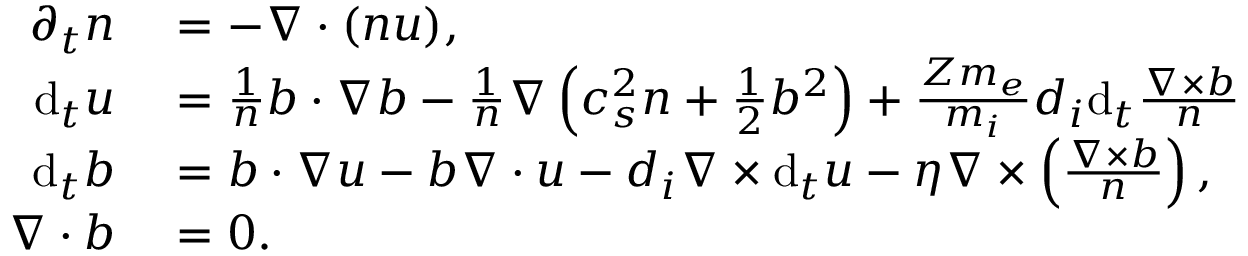<formula> <loc_0><loc_0><loc_500><loc_500>\begin{array} { r l } { \partial _ { t } n } & = - \nabla \cdot ( n u ) , } \\ { d _ { t } u } & = \frac { 1 } { n } b \cdot \nabla b - \frac { 1 } { n } \nabla \left ( c _ { s } ^ { 2 } n + \frac { 1 } { 2 } b ^ { 2 } \right ) + \frac { Z m _ { e } } { m _ { i } } d _ { i } d _ { t } \frac { \nabla \times b } { n } } \\ { d _ { t } b } & = b \cdot \nabla u - b \nabla \cdot u - d _ { i } \nabla \times d _ { t } u - \eta \nabla \times \left ( \frac { \nabla \times b } { n } \right ) , } \\ { \nabla \cdot b } & = 0 . } \end{array}</formula> 